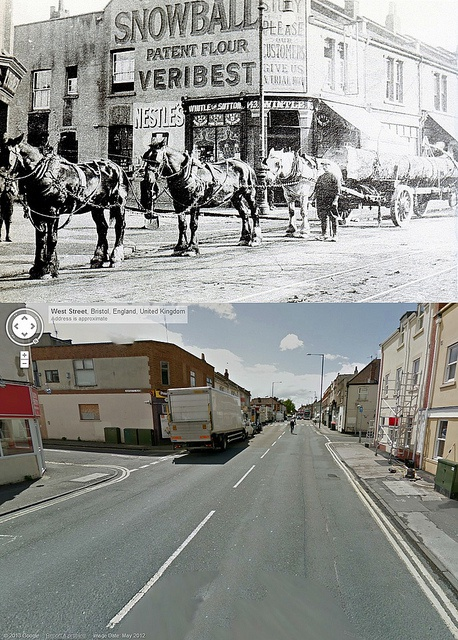Describe the objects in this image and their specific colors. I can see horse in ivory, black, lightgray, darkgray, and gray tones, horse in ivory, black, lightgray, darkgray, and gray tones, truck in ivory, gray, and black tones, horse in ivory, white, darkgray, gray, and black tones, and people in ivory, black, gray, darkgray, and lightgray tones in this image. 